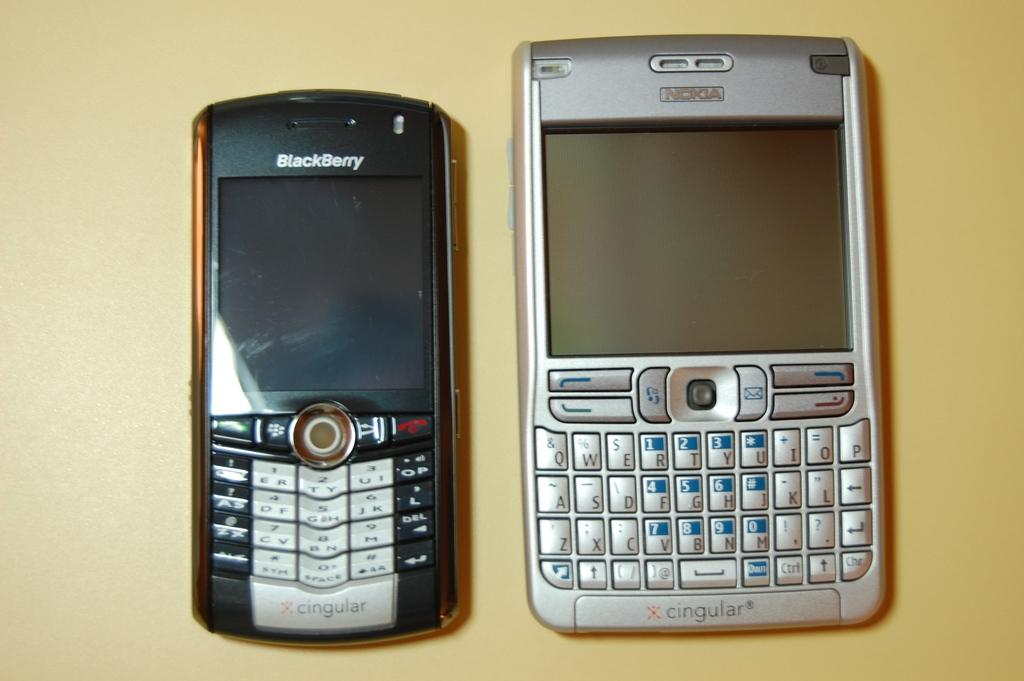<image>
Write a terse but informative summary of the picture. A smaller Blackberry device sitting next to a larger silver Nokia device. 